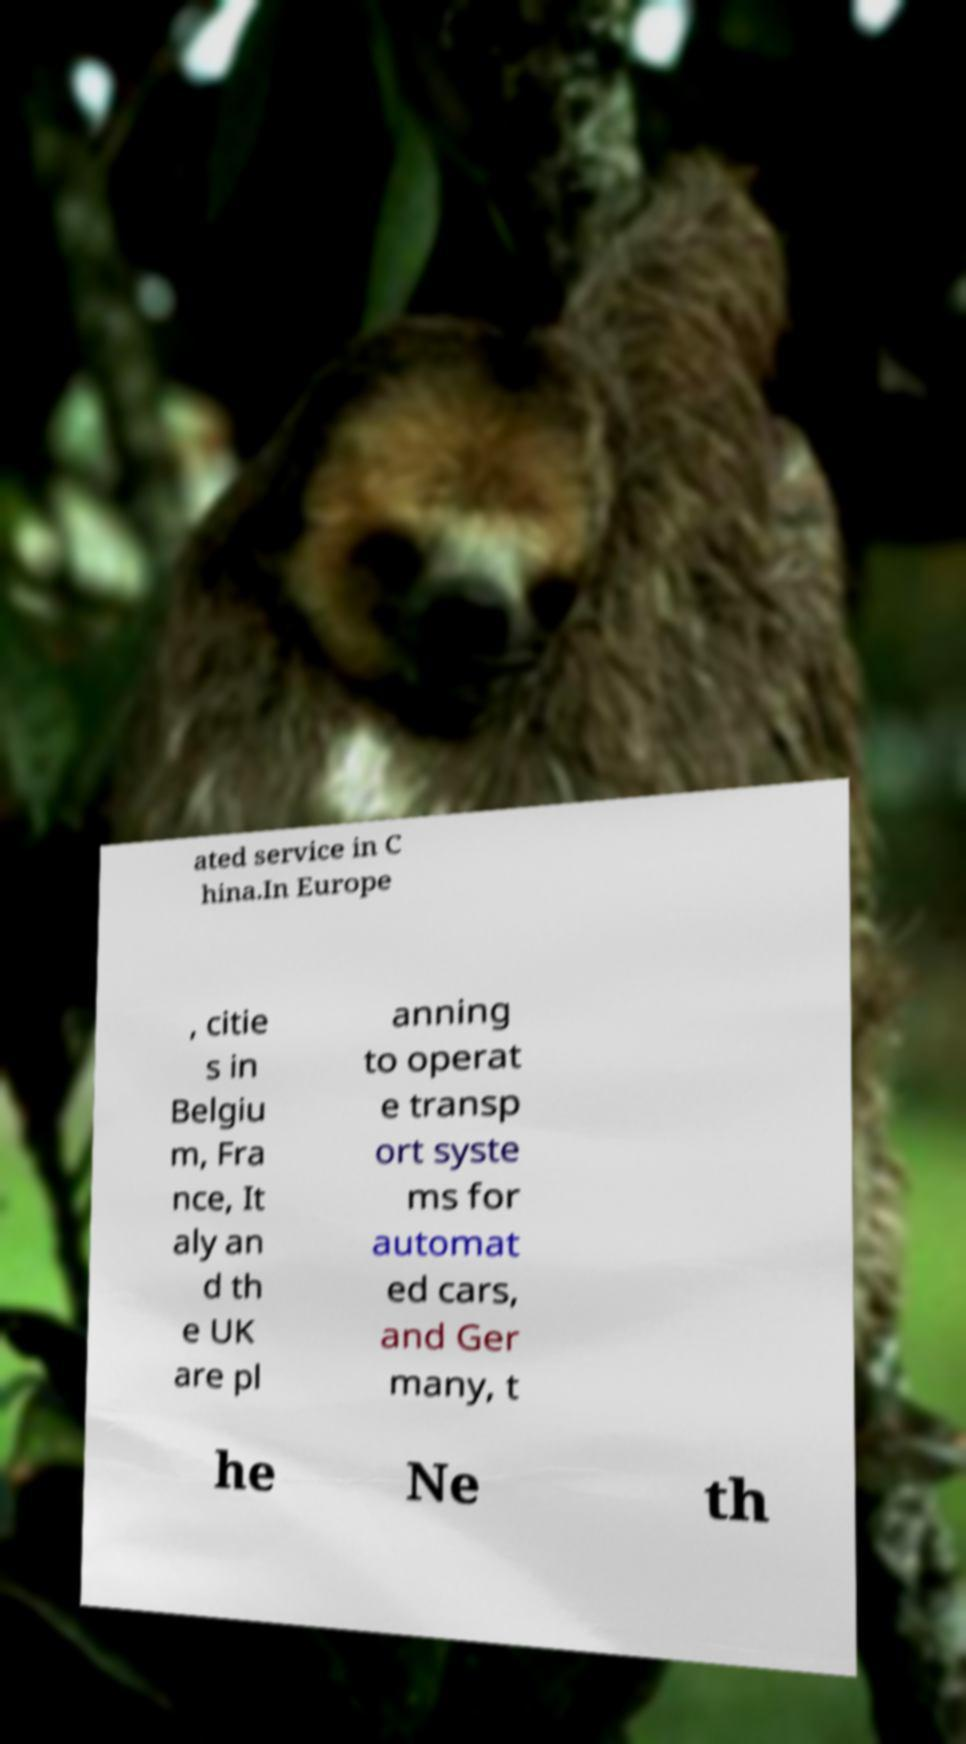Could you assist in decoding the text presented in this image and type it out clearly? ated service in C hina.In Europe , citie s in Belgiu m, Fra nce, It aly an d th e UK are pl anning to operat e transp ort syste ms for automat ed cars, and Ger many, t he Ne th 